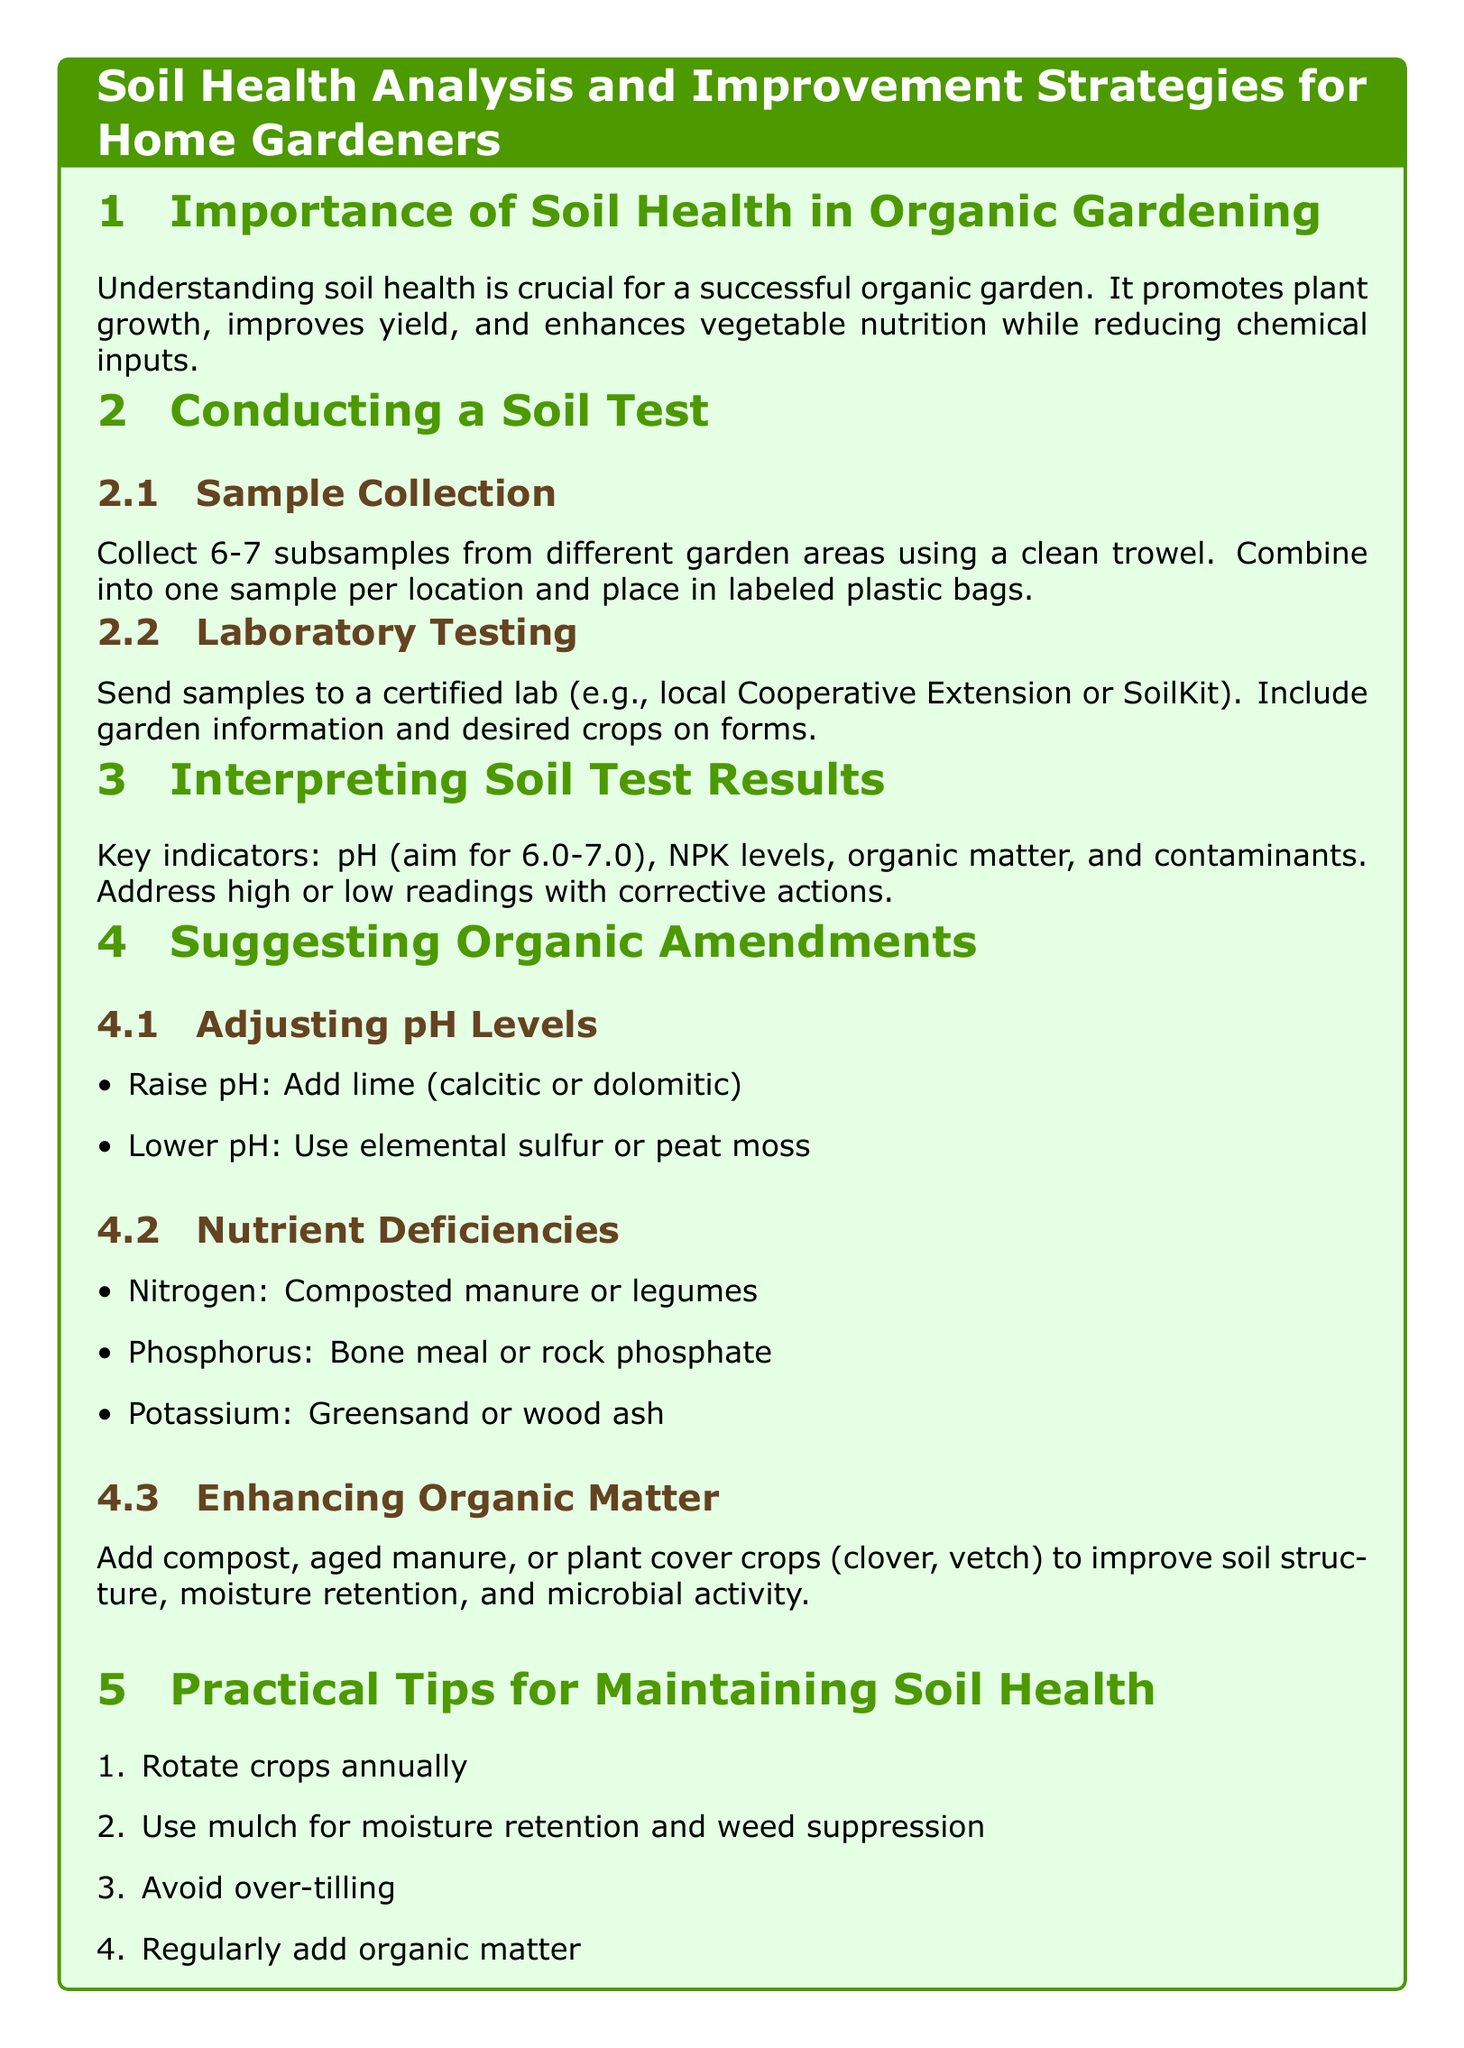What is the ideal pH level for soil in organic gardening? The document states that the ideal pH level for soil is between 6.0 to 7.0.
Answer: 6.0-7.0 What should be added to raise the pH of the soil? To raise the pH, the document suggests adding lime (calcitic or dolomitic).
Answer: Lime What is a suggested amendment for nitrogen deficiency? The document recommends using composted manure or legumes to address nitrogen deficiency.
Answer: Composted manure Which substance can lower the pH of the soil? The document mentions using elemental sulfur or peat moss for lowering the pH.
Answer: Elemental sulfur What is a method for enhancing organic matter in the soil? The document suggests adding compost, aged manure, or planting cover crops.
Answer: Compost How many subsamples should be collected for a soil test? According to the document, 6-7 subsamples should be collected for a soil test.
Answer: 6-7 What is one practical tip for maintaining soil health? The document lists rotating crops annually as a practical tip for maintaining soil health.
Answer: Rotate crops annually Where should soil samples be sent for testing? The document states that samples should be sent to a certified lab, such as a local Cooperative Extension or SoilKit.
Answer: Certified lab 